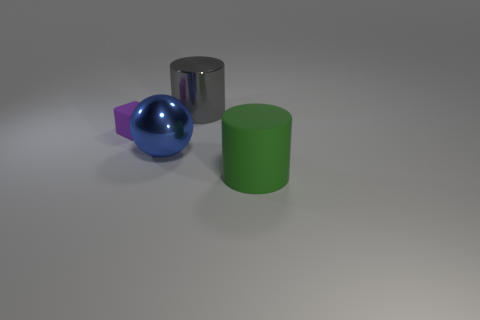Subtract all gray cylinders. How many cylinders are left? 1 Subtract 1 spheres. How many spheres are left? 0 Subtract all spheres. How many objects are left? 3 Subtract all green cylinders. Subtract all yellow blocks. How many cylinders are left? 1 Subtract all yellow cylinders. How many gray balls are left? 0 Add 2 large gray things. How many objects exist? 6 Subtract 0 brown blocks. How many objects are left? 4 Subtract all large gray cylinders. Subtract all purple rubber things. How many objects are left? 2 Add 3 big green rubber objects. How many big green rubber objects are left? 4 Add 2 purple matte objects. How many purple matte objects exist? 3 